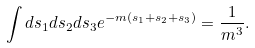<formula> <loc_0><loc_0><loc_500><loc_500>\int d s _ { 1 } d s _ { 2 } d s _ { 3 } e ^ { - m ( s _ { 1 } + s _ { 2 } + s _ { 3 } ) } = \frac { 1 } { m ^ { 3 } } .</formula> 